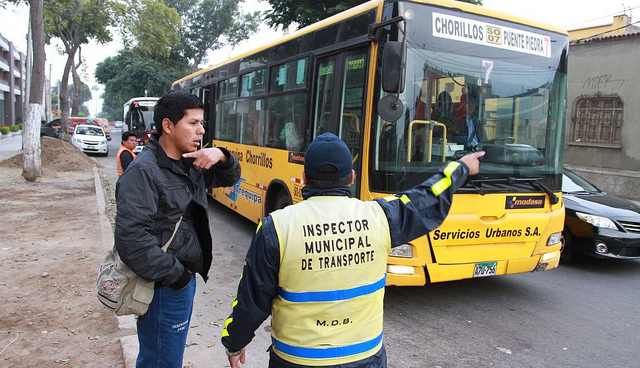Read all the text in this image. 7 S.A Urbanos Servicios TRANSPORTE DE MUNICIPAL Chomilos 